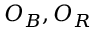<formula> <loc_0><loc_0><loc_500><loc_500>O _ { B } , O _ { R }</formula> 